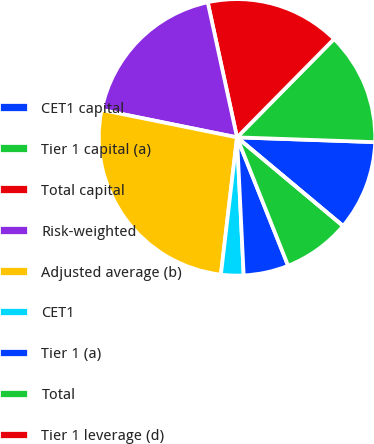Convert chart. <chart><loc_0><loc_0><loc_500><loc_500><pie_chart><fcel>CET1 capital<fcel>Tier 1 capital (a)<fcel>Total capital<fcel>Risk-weighted<fcel>Adjusted average (b)<fcel>CET1<fcel>Tier 1 (a)<fcel>Total<fcel>Tier 1 leverage (d)<nl><fcel>10.53%<fcel>13.16%<fcel>15.79%<fcel>18.42%<fcel>26.32%<fcel>2.63%<fcel>5.26%<fcel>7.89%<fcel>0.0%<nl></chart> 